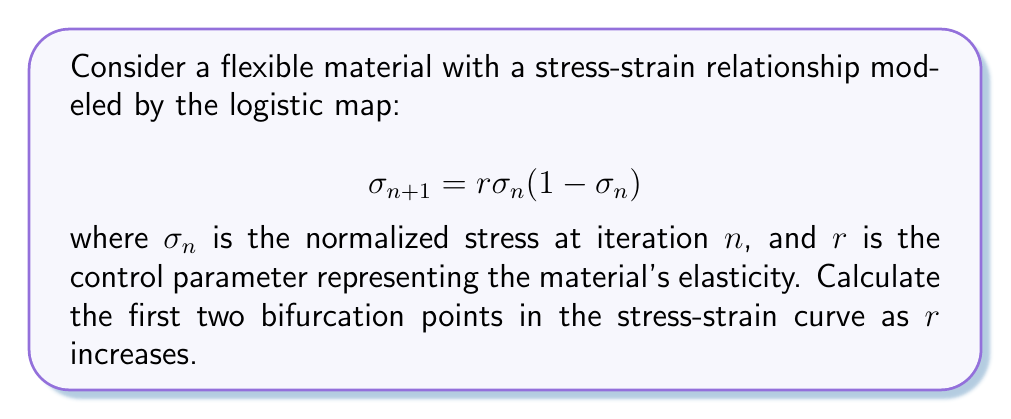Solve this math problem. To find the bifurcation points, we need to analyze the stability of the fixed points in the logistic map:

1. Find the fixed points:
   Set $\sigma_{n+1} = \sigma_n = \sigma^*$
   $$\sigma^* = r\sigma^*(1-\sigma^*)$$
   Solving this equation gives two fixed points:
   $$\sigma^*_1 = 0 \text{ and } \sigma^*_2 = 1 - \frac{1}{r}$$

2. Analyze stability:
   The derivative of the map is:
   $$\frac{d\sigma_{n+1}}{d\sigma_n} = r(1-2\sigma_n)$$

3. First bifurcation point:
   The non-zero fixed point $\sigma^*_2$ loses stability when:
   $$|\frac{d\sigma_{n+1}}{d\sigma_n}| = |r(1-2\sigma^*_2)| = |-r(1-2(1-\frac{1}{r}))| = |2-r| = 1$$
   Solving this equation: $r = 3$

4. Second bifurcation point:
   After the first bifurcation, the system oscillates between two values. The second bifurcation occurs when this 2-cycle loses stability.
   The 2-cycle satisfies:
   $$\sigma_2 = r\sigma_1(1-\sigma_1)$$
   $$\sigma_1 = r\sigma_2(1-\sigma_2)$$
   
   The stability is determined by the product of derivatives:
   $$|\frac{d\sigma_2}{d\sigma_1} \cdot \frac{d\sigma_1}{d\sigma_2}| = |r(1-2\sigma_1) \cdot r(1-2\sigma_2)| = 1$$
   
   This leads to the equation:
   $$r^2(1-2\sigma_1)(1-2\sigma_2) = -1$$
   
   Solving this numerically gives: $r \approx 3.449490$

Therefore, the first two bifurcation points occur at $r = 3$ and $r \approx 3.449490$.
Answer: $r_1 = 3$, $r_2 \approx 3.449490$ 